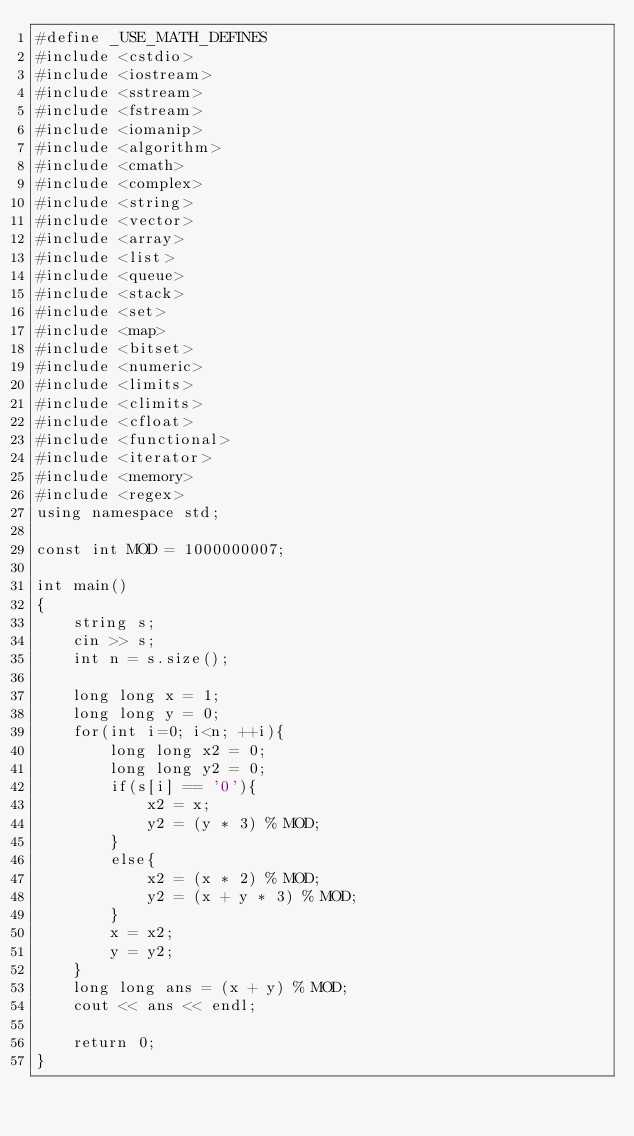Convert code to text. <code><loc_0><loc_0><loc_500><loc_500><_C++_>#define _USE_MATH_DEFINES
#include <cstdio>
#include <iostream>
#include <sstream>
#include <fstream>
#include <iomanip>
#include <algorithm>
#include <cmath>
#include <complex>
#include <string>
#include <vector>
#include <array>
#include <list>
#include <queue>
#include <stack>
#include <set>
#include <map>
#include <bitset>
#include <numeric>
#include <limits>
#include <climits>
#include <cfloat>
#include <functional>
#include <iterator>
#include <memory>
#include <regex>
using namespace std;

const int MOD = 1000000007;

int main()
{
    string s;
    cin >> s;
    int n = s.size();

    long long x = 1;
    long long y = 0;
    for(int i=0; i<n; ++i){
        long long x2 = 0;
        long long y2 = 0;
        if(s[i] == '0'){
            x2 = x;
            y2 = (y * 3) % MOD;
        }
        else{
            x2 = (x * 2) % MOD;
            y2 = (x + y * 3) % MOD;
        }
        x = x2;
        y = y2;
    }
    long long ans = (x + y) % MOD;
    cout << ans << endl;

    return 0;
}
</code> 